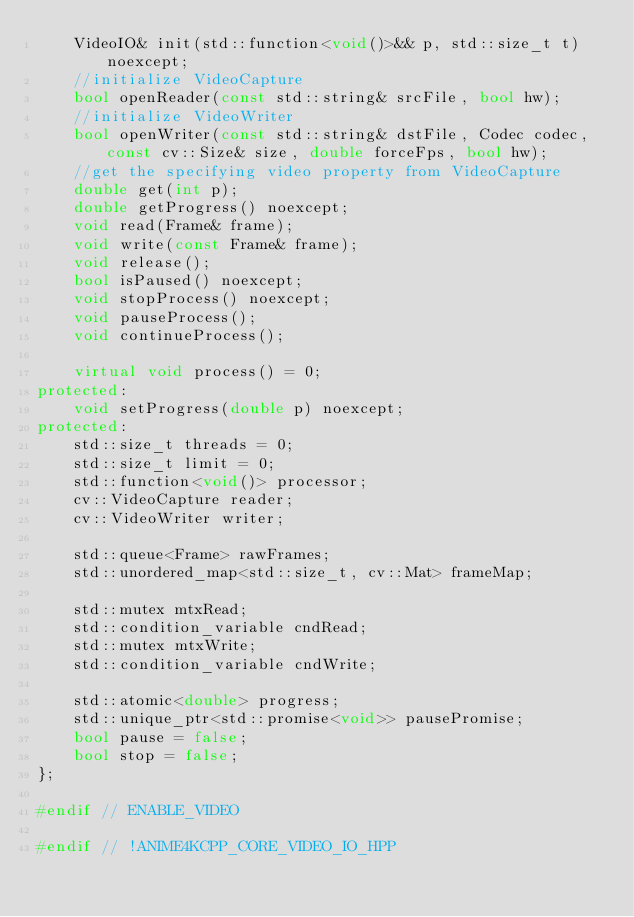Convert code to text. <code><loc_0><loc_0><loc_500><loc_500><_C++_>    VideoIO& init(std::function<void()>&& p, std::size_t t) noexcept;
    //initialize VideoCapture
    bool openReader(const std::string& srcFile, bool hw);
    //initialize VideoWriter
    bool openWriter(const std::string& dstFile, Codec codec, const cv::Size& size, double forceFps, bool hw);
    //get the specifying video property from VideoCapture
    double get(int p);
    double getProgress() noexcept;
    void read(Frame& frame);
    void write(const Frame& frame);
    void release();
    bool isPaused() noexcept;
    void stopProcess() noexcept;
    void pauseProcess();
    void continueProcess();

    virtual void process() = 0;
protected:
    void setProgress(double p) noexcept;
protected:
    std::size_t threads = 0;
    std::size_t limit = 0;
    std::function<void()> processor;
    cv::VideoCapture reader;
    cv::VideoWriter writer;

    std::queue<Frame> rawFrames;
    std::unordered_map<std::size_t, cv::Mat> frameMap;

    std::mutex mtxRead;
    std::condition_variable cndRead;
    std::mutex mtxWrite;
    std::condition_variable cndWrite;

    std::atomic<double> progress;
    std::unique_ptr<std::promise<void>> pausePromise;
    bool pause = false;
    bool stop = false;
};

#endif // ENABLE_VIDEO

#endif // !ANIME4KCPP_CORE_VIDEO_IO_HPP
</code> 